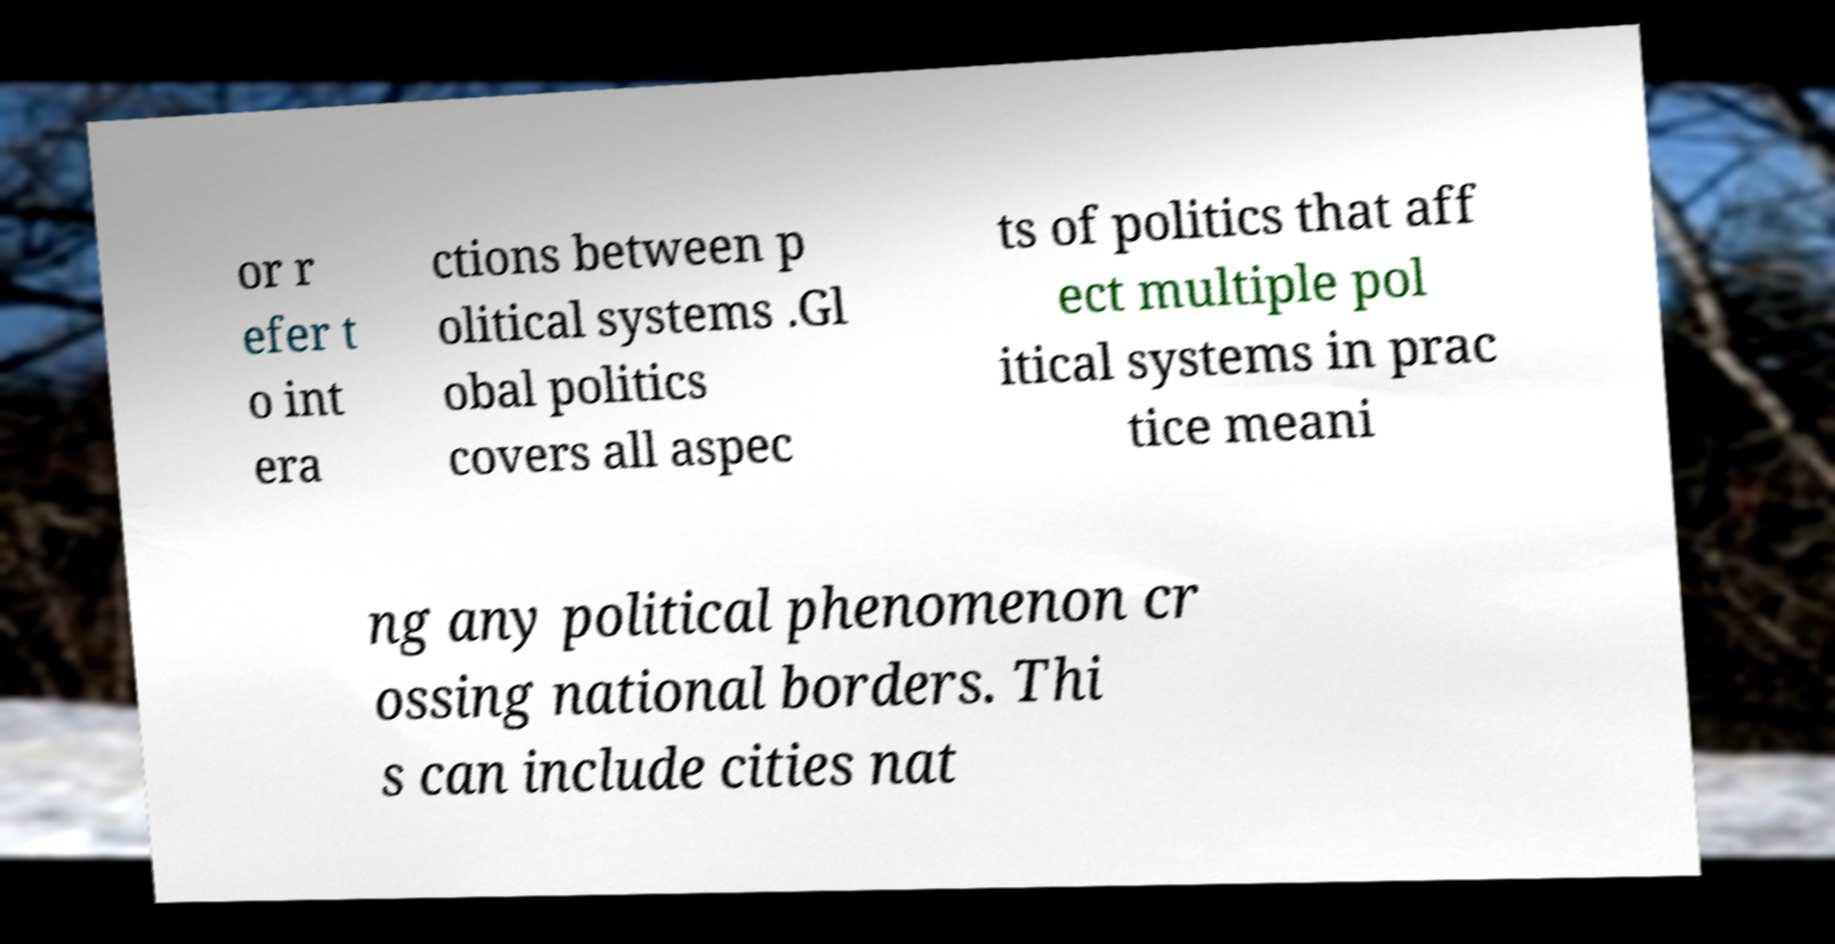There's text embedded in this image that I need extracted. Can you transcribe it verbatim? or r efer t o int era ctions between p olitical systems .Gl obal politics covers all aspec ts of politics that aff ect multiple pol itical systems in prac tice meani ng any political phenomenon cr ossing national borders. Thi s can include cities nat 